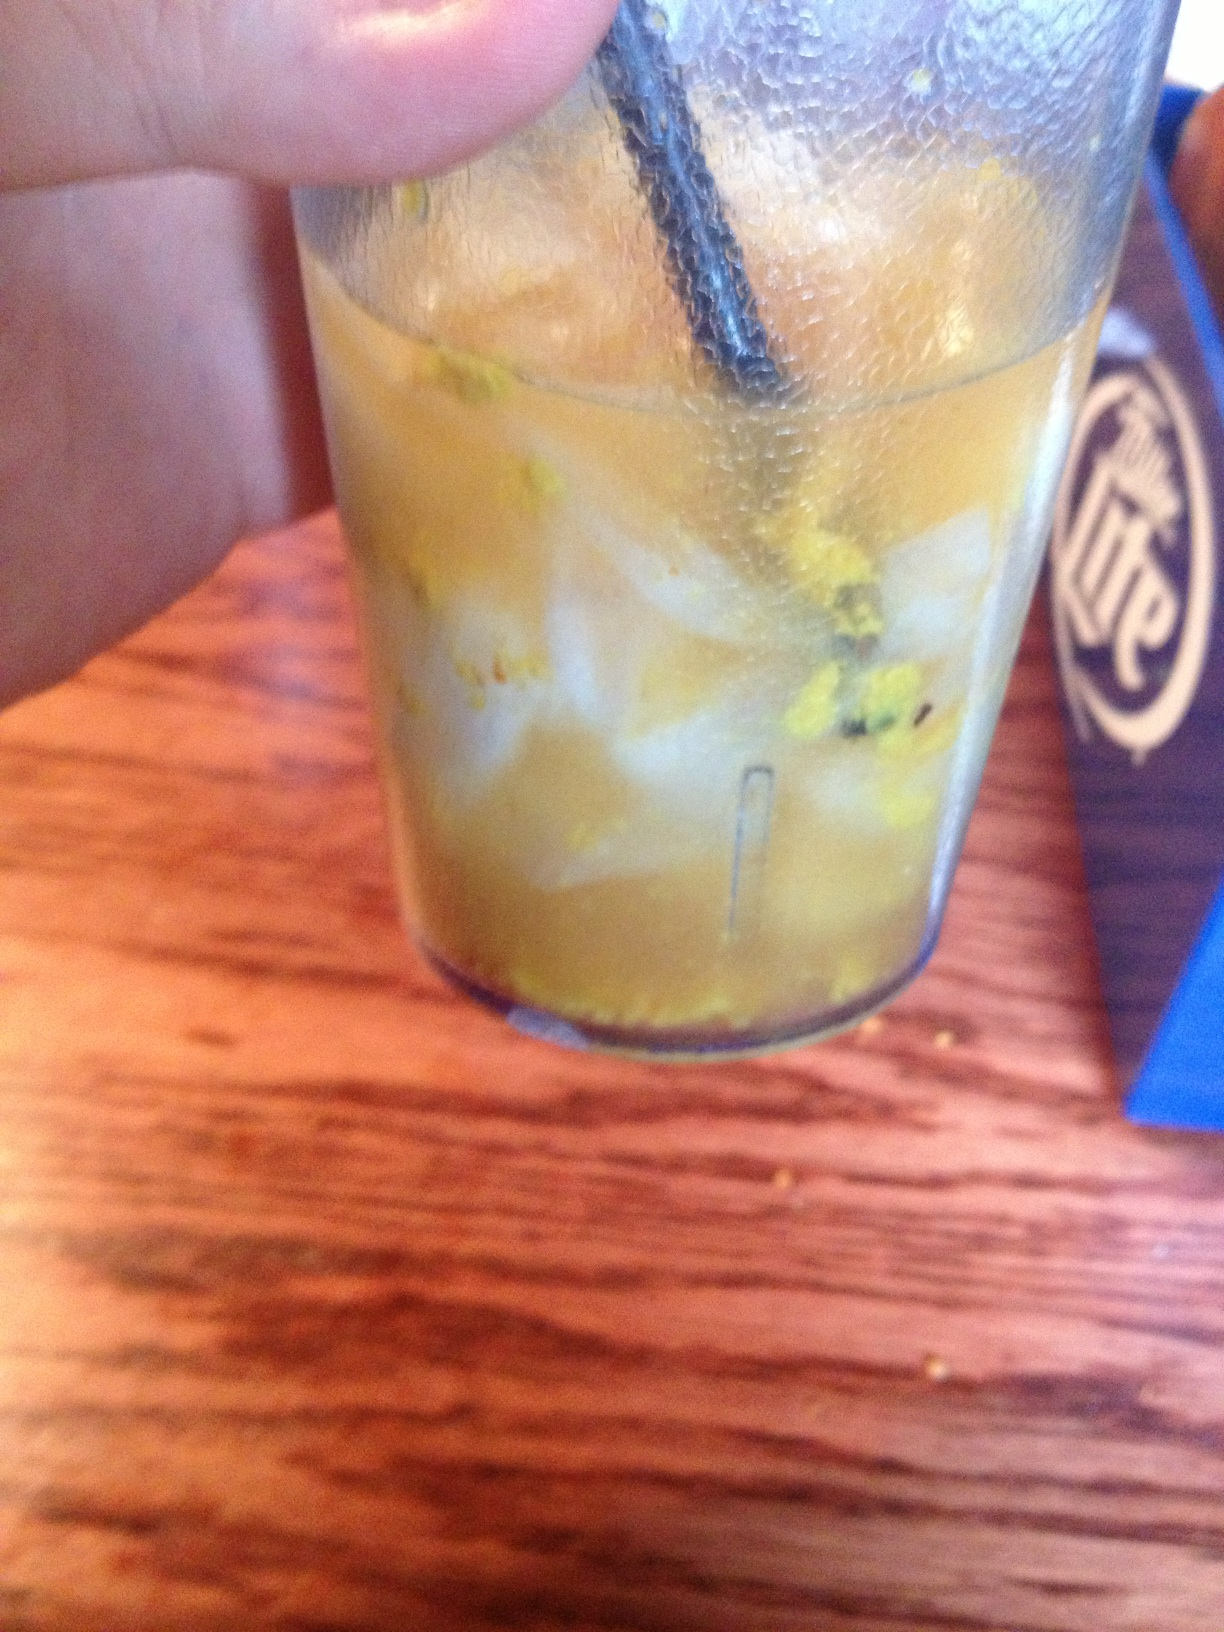I was just served this at a restaurant and I'm wondering what it is because it tastes funny. It appears you've been served a drink with an unusual appearance, possibly containing some floating particles or grated zest. It might be best to send it back and ask for a different beverage, as it could be a sign of improper preparation or contamination. 